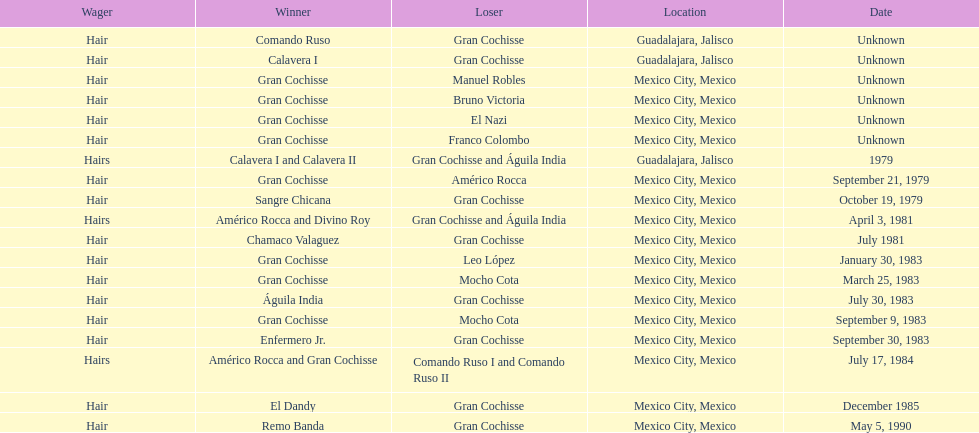What is the frequency of the hair wager? 16. 